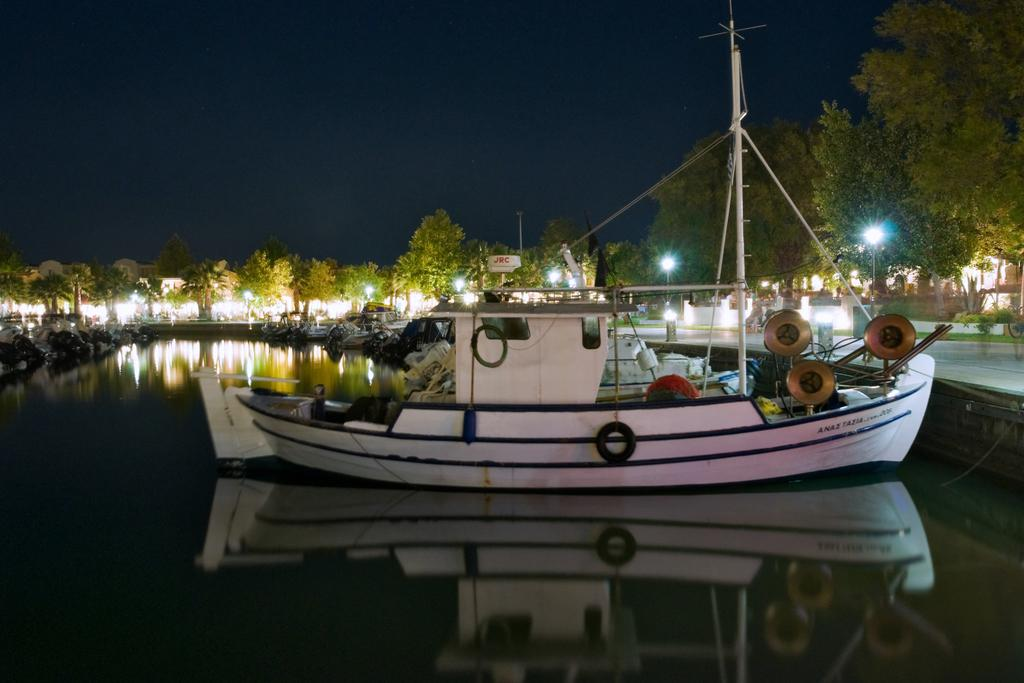What is the color of the boat in the image? The boat in the image is white. Where is the boat located? The boat is in the water. What can be seen in the background of the image? There is a party ground visible in the background. What features are present on the party ground? There are many trees and lights on the party ground. What is the best route to take to the thrilling week event on the party ground? The image does not provide information about a route or a thrilling week event, so it cannot be answered definitively. 